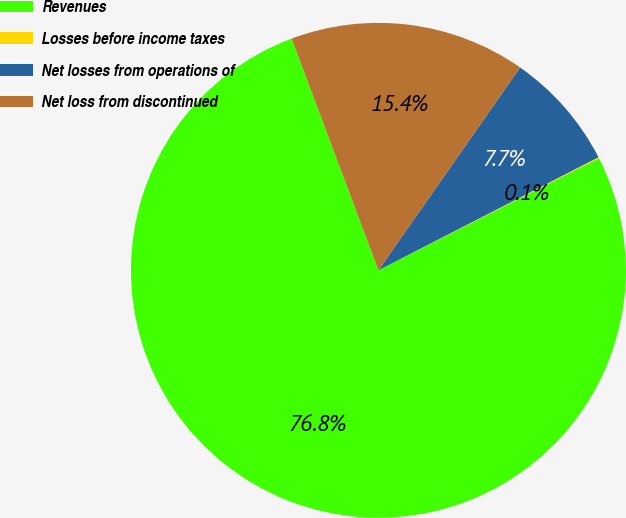Convert chart. <chart><loc_0><loc_0><loc_500><loc_500><pie_chart><fcel>Revenues<fcel>Losses before income taxes<fcel>Net losses from operations of<fcel>Net loss from discontinued<nl><fcel>76.77%<fcel>0.07%<fcel>7.74%<fcel>15.41%<nl></chart> 